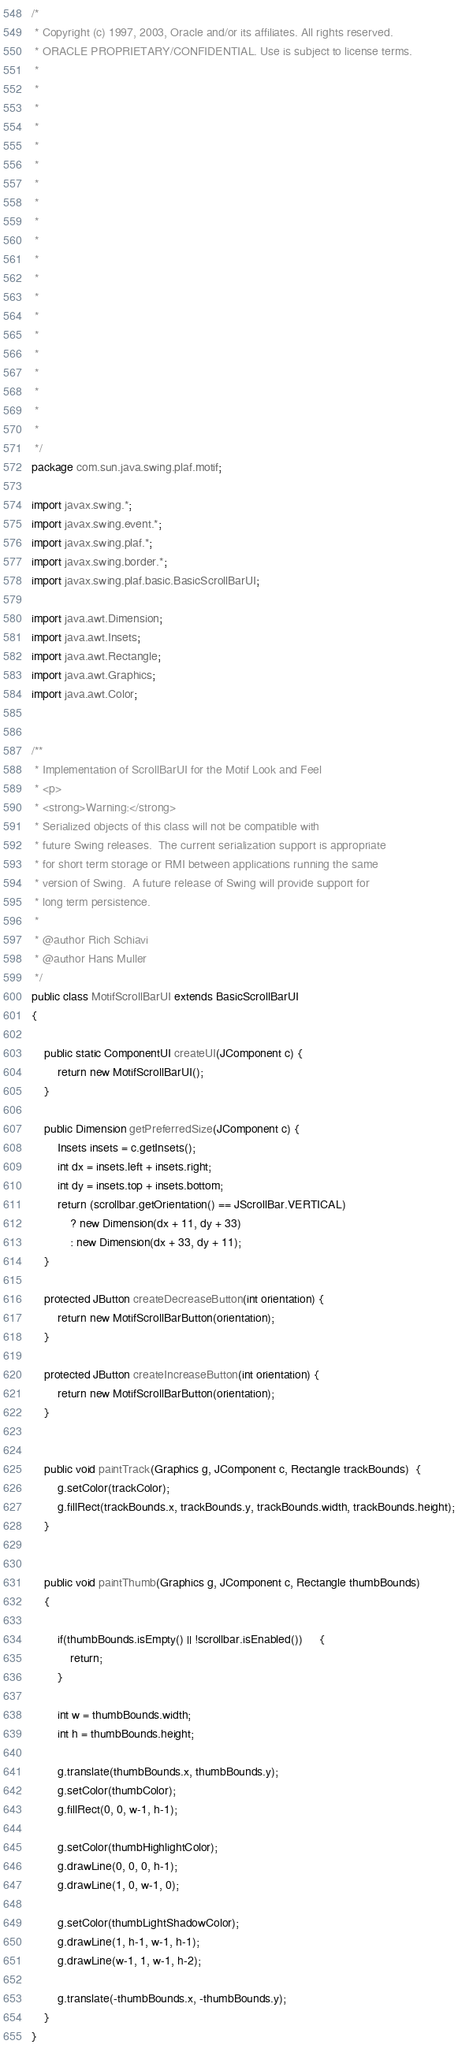Convert code to text. <code><loc_0><loc_0><loc_500><loc_500><_Java_>/*
 * Copyright (c) 1997, 2003, Oracle and/or its affiliates. All rights reserved.
 * ORACLE PROPRIETARY/CONFIDENTIAL. Use is subject to license terms.
 *
 *
 *
 *
 *
 *
 *
 *
 *
 *
 *
 *
 *
 *
 *
 *
 *
 *
 *
 *
 */
package com.sun.java.swing.plaf.motif;

import javax.swing.*;
import javax.swing.event.*;
import javax.swing.plaf.*;
import javax.swing.border.*;
import javax.swing.plaf.basic.BasicScrollBarUI;

import java.awt.Dimension;
import java.awt.Insets;
import java.awt.Rectangle;
import java.awt.Graphics;
import java.awt.Color;


/**
 * Implementation of ScrollBarUI for the Motif Look and Feel
 * <p>
 * <strong>Warning:</strong>
 * Serialized objects of this class will not be compatible with
 * future Swing releases.  The current serialization support is appropriate
 * for short term storage or RMI between applications running the same
 * version of Swing.  A future release of Swing will provide support for
 * long term persistence.
 *
 * @author Rich Schiavi
 * @author Hans Muller
 */
public class MotifScrollBarUI extends BasicScrollBarUI
{

    public static ComponentUI createUI(JComponent c) {
        return new MotifScrollBarUI();
    }

    public Dimension getPreferredSize(JComponent c) {
        Insets insets = c.getInsets();
        int dx = insets.left + insets.right;
        int dy = insets.top + insets.bottom;
        return (scrollbar.getOrientation() == JScrollBar.VERTICAL)
            ? new Dimension(dx + 11, dy + 33)
            : new Dimension(dx + 33, dy + 11);
    }

    protected JButton createDecreaseButton(int orientation) {
        return new MotifScrollBarButton(orientation);
    }

    protected JButton createIncreaseButton(int orientation) {
        return new MotifScrollBarButton(orientation);
    }


    public void paintTrack(Graphics g, JComponent c, Rectangle trackBounds)  {
        g.setColor(trackColor);
        g.fillRect(trackBounds.x, trackBounds.y, trackBounds.width, trackBounds.height);
    }


    public void paintThumb(Graphics g, JComponent c, Rectangle thumbBounds)
    {

        if(thumbBounds.isEmpty() || !scrollbar.isEnabled())     {
            return;
        }

        int w = thumbBounds.width;
        int h = thumbBounds.height;

        g.translate(thumbBounds.x, thumbBounds.y);
        g.setColor(thumbColor);
        g.fillRect(0, 0, w-1, h-1);

        g.setColor(thumbHighlightColor);
        g.drawLine(0, 0, 0, h-1);
        g.drawLine(1, 0, w-1, 0);

        g.setColor(thumbLightShadowColor);
        g.drawLine(1, h-1, w-1, h-1);
        g.drawLine(w-1, 1, w-1, h-2);

        g.translate(-thumbBounds.x, -thumbBounds.y);
    }
}
</code> 